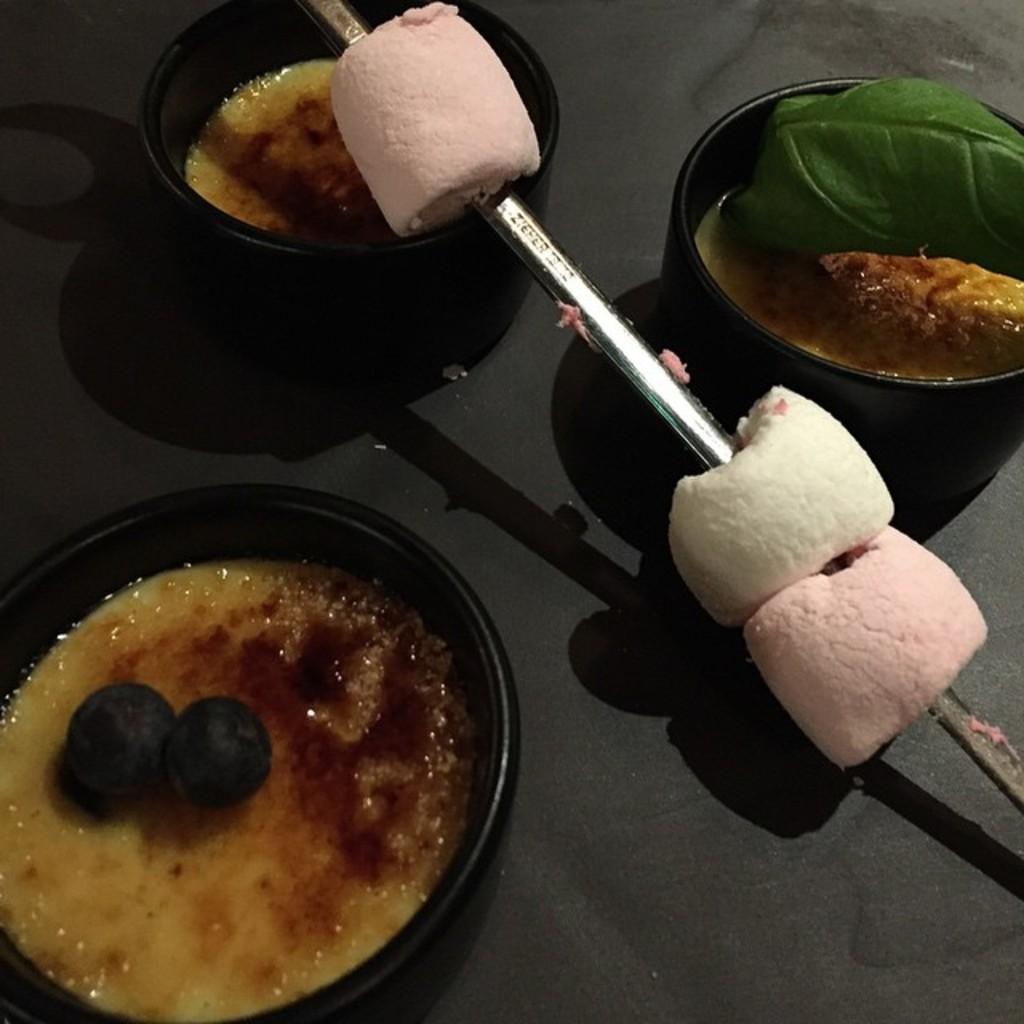Describe this image in one or two sentences. In this image there is a black color bowl filled with some food items on the left side of this image and also on the top of this image as well, and there is a food item kept on the floor on the right side of this image is in white color. and as we can see there is a floor in the background. 